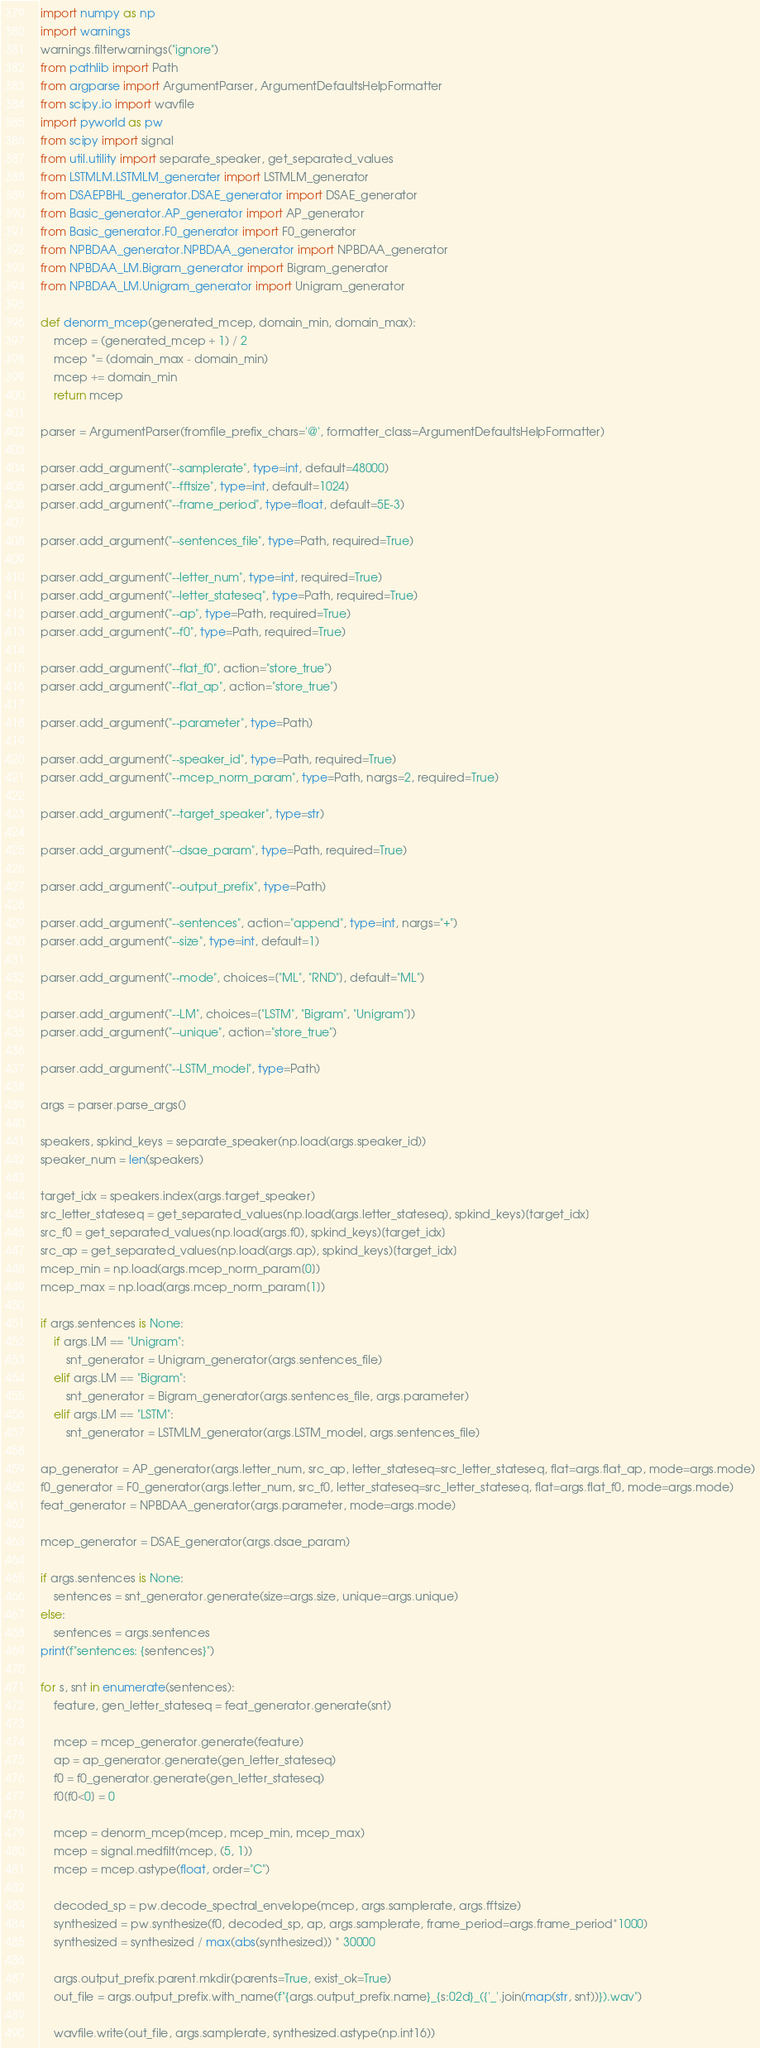Convert code to text. <code><loc_0><loc_0><loc_500><loc_500><_Python_>import numpy as np
import warnings
warnings.filterwarnings("ignore")
from pathlib import Path
from argparse import ArgumentParser, ArgumentDefaultsHelpFormatter
from scipy.io import wavfile
import pyworld as pw
from scipy import signal
from util.utility import separate_speaker, get_separated_values
from LSTMLM.LSTMLM_generater import LSTMLM_generator
from DSAEPBHL_generator.DSAE_generator import DSAE_generator
from Basic_generator.AP_generator import AP_generator
from Basic_generator.F0_generator import F0_generator
from NPBDAA_generator.NPBDAA_generator import NPBDAA_generator
from NPBDAA_LM.Bigram_generator import Bigram_generator
from NPBDAA_LM.Unigram_generator import Unigram_generator

def denorm_mcep(generated_mcep, domain_min, domain_max):
    mcep = (generated_mcep + 1) / 2
    mcep *= (domain_max - domain_min)
    mcep += domain_min
    return mcep

parser = ArgumentParser(fromfile_prefix_chars='@', formatter_class=ArgumentDefaultsHelpFormatter)

parser.add_argument("--samplerate", type=int, default=48000)
parser.add_argument("--fftsize", type=int, default=1024)
parser.add_argument("--frame_period", type=float, default=5E-3)

parser.add_argument("--sentences_file", type=Path, required=True)

parser.add_argument("--letter_num", type=int, required=True)
parser.add_argument("--letter_stateseq", type=Path, required=True)
parser.add_argument("--ap", type=Path, required=True)
parser.add_argument("--f0", type=Path, required=True)

parser.add_argument("--flat_f0", action="store_true")
parser.add_argument("--flat_ap", action="store_true")

parser.add_argument("--parameter", type=Path)

parser.add_argument("--speaker_id", type=Path, required=True)
parser.add_argument("--mcep_norm_param", type=Path, nargs=2, required=True)

parser.add_argument("--target_speaker", type=str)

parser.add_argument("--dsae_param", type=Path, required=True)

parser.add_argument("--output_prefix", type=Path)

parser.add_argument("--sentences", action="append", type=int, nargs="+")
parser.add_argument("--size", type=int, default=1)

parser.add_argument("--mode", choices=["ML", "RND"], default="ML")

parser.add_argument("--LM", choices=["LSTM", "Bigram", "Unigram"])
parser.add_argument("--unique", action="store_true")

parser.add_argument("--LSTM_model", type=Path)

args = parser.parse_args()

speakers, spkind_keys = separate_speaker(np.load(args.speaker_id))
speaker_num = len(speakers)

target_idx = speakers.index(args.target_speaker)
src_letter_stateseq = get_separated_values(np.load(args.letter_stateseq), spkind_keys)[target_idx]
src_f0 = get_separated_values(np.load(args.f0), spkind_keys)[target_idx]
src_ap = get_separated_values(np.load(args.ap), spkind_keys)[target_idx]
mcep_min = np.load(args.mcep_norm_param[0])
mcep_max = np.load(args.mcep_norm_param[1])

if args.sentences is None:
    if args.LM == "Unigram":
        snt_generator = Unigram_generator(args.sentences_file)
    elif args.LM == "Bigram":
        snt_generator = Bigram_generator(args.sentences_file, args.parameter)
    elif args.LM == "LSTM":
        snt_generator = LSTMLM_generator(args.LSTM_model, args.sentences_file)

ap_generator = AP_generator(args.letter_num, src_ap, letter_stateseq=src_letter_stateseq, flat=args.flat_ap, mode=args.mode)
f0_generator = F0_generator(args.letter_num, src_f0, letter_stateseq=src_letter_stateseq, flat=args.flat_f0, mode=args.mode)
feat_generator = NPBDAA_generator(args.parameter, mode=args.mode)

mcep_generator = DSAE_generator(args.dsae_param)

if args.sentences is None:
    sentences = snt_generator.generate(size=args.size, unique=args.unique)
else:
    sentences = args.sentences
print(f"sentences: {sentences}")

for s, snt in enumerate(sentences):
    feature, gen_letter_stateseq = feat_generator.generate(snt)

    mcep = mcep_generator.generate(feature)
    ap = ap_generator.generate(gen_letter_stateseq)
    f0 = f0_generator.generate(gen_letter_stateseq)
    f0[f0<0] = 0

    mcep = denorm_mcep(mcep, mcep_min, mcep_max)
    mcep = signal.medfilt(mcep, (5, 1))
    mcep = mcep.astype(float, order="C")

    decoded_sp = pw.decode_spectral_envelope(mcep, args.samplerate, args.fftsize)
    synthesized = pw.synthesize(f0, decoded_sp, ap, args.samplerate, frame_period=args.frame_period*1000)
    synthesized = synthesized / max(abs(synthesized)) * 30000

    args.output_prefix.parent.mkdir(parents=True, exist_ok=True)
    out_file = args.output_prefix.with_name(f"{args.output_prefix.name}_{s:02d}_({'_'.join(map(str, snt))}).wav")

    wavfile.write(out_file, args.samplerate, synthesized.astype(np.int16))
</code> 